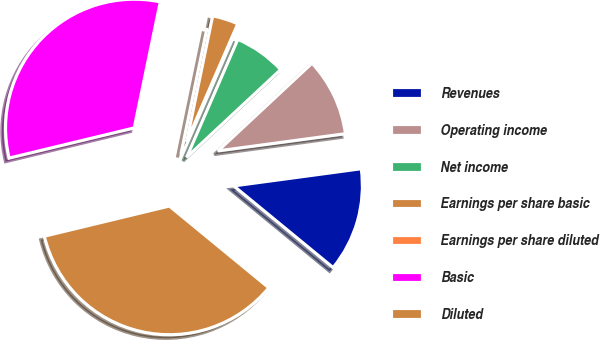Convert chart to OTSL. <chart><loc_0><loc_0><loc_500><loc_500><pie_chart><fcel>Revenues<fcel>Operating income<fcel>Net income<fcel>Earnings per share basic<fcel>Earnings per share diluted<fcel>Basic<fcel>Diluted<nl><fcel>13.08%<fcel>9.81%<fcel>6.54%<fcel>3.27%<fcel>0.0%<fcel>32.01%<fcel>35.28%<nl></chart> 